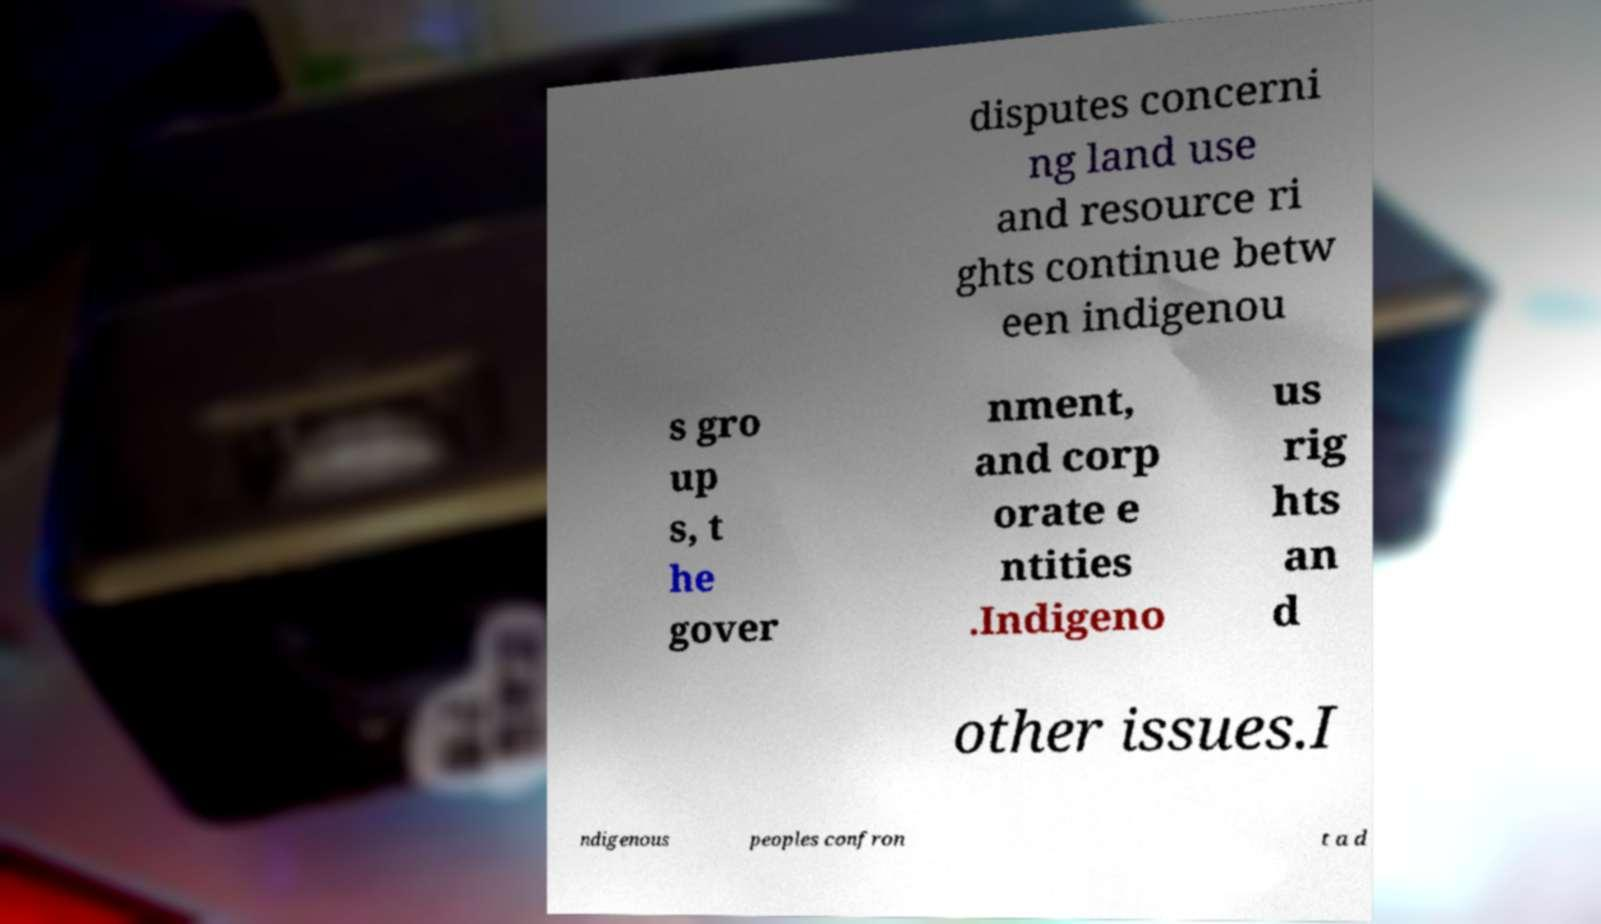Could you extract and type out the text from this image? disputes concerni ng land use and resource ri ghts continue betw een indigenou s gro up s, t he gover nment, and corp orate e ntities .Indigeno us rig hts an d other issues.I ndigenous peoples confron t a d 